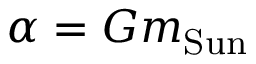Convert formula to latex. <formula><loc_0><loc_0><loc_500><loc_500>\alpha = G m _ { S u n }</formula> 